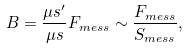<formula> <loc_0><loc_0><loc_500><loc_500>B = \frac { \mu s ^ { \prime } } { \mu s } F _ { m e s s } \sim \frac { F _ { m e s s } } { S _ { m e s s } } ,</formula> 